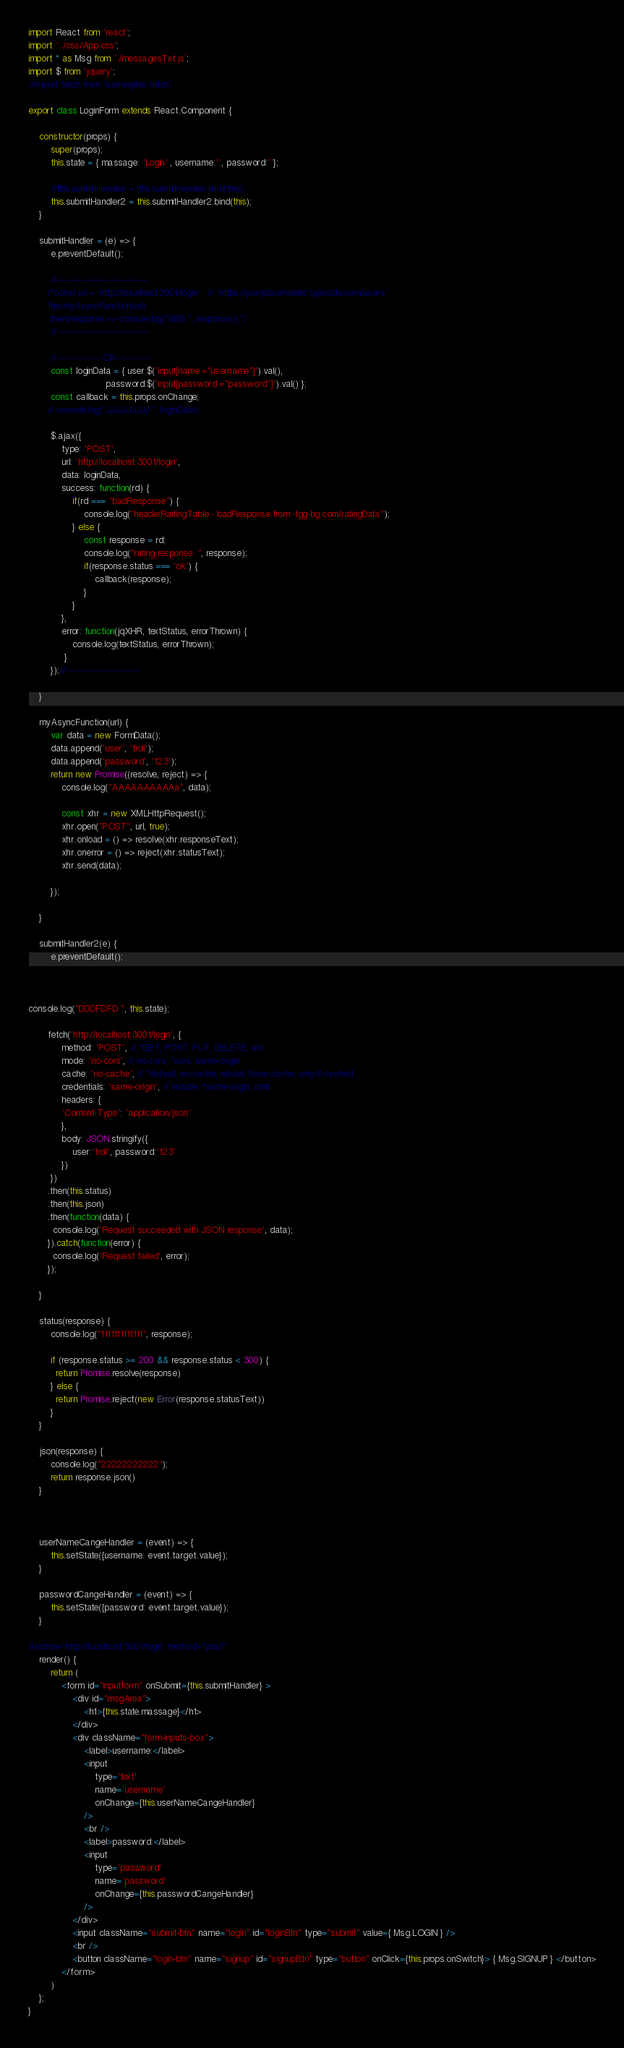<code> <loc_0><loc_0><loc_500><loc_500><_JavaScript_>import React from 'react';
import '../css/App.css';
import * as Msg from './messagesTxt.js';
import $ from 'jquery';
//import fetch from 'isomorphic-fetch';

export class LoginForm extends React.Component {

    constructor(props) {
        super(props);
        this.state = { massage: 'Login' , username:'', password:''};

        //this.submitHandler = this.submitHandler.bind(this);
        this.submitHandler2 = this.submitHandler2.bind(this);
    }

    submitHandler = (e) => {
        e.preventDefault();

        //---------------------------------
       /*const url = 'http://localhost:3001/login';  // 'https://jsonplaceholder.typicode.com/users'
       this.myAsyncFunction(url)
       .then(response => console.log("BBB ", response));*/
        //----------------------------------

        //-----------------OK-------------
        const loginData = { user:$('input[name ="username"]').val(),
                            password:$('input[password ="password"]').val() };
        const callback = this.props.onChange;
       // console.log("JJJJJJJJJJ ", loginData);

        $.ajax({
            type: 'POST',
            url: 'http://localhost:3001/login',
            data: loginData,
            success: function(rd) {
                if(rd === "badResponse") {
                    console.log("headerRaitingTable - badResponse from -tgg-bg.com/ratingData");
                } else {
                    const response = rd;
                    console.log("rating response: ", response);
                    if(response.status === 'ok') {
                        callback(response);
                    }
                }
            },
            error: function(jqXHR, textStatus, errorThrown) {
                console.log(textStatus, errorThrown);
             }
        });//---------------------------

    }

    myAsyncFunction(url) {
        var data = new FormData();
        data.append('user', 'troll');
        data.append('password', '123');
        return new Promise((resolve, reject) => {
            console.log("AAAAAAAAAAa", data);
            
            const xhr = new XMLHttpRequest();
            xhr.open("POST", url, true);
            xhr.onload = () => resolve(xhr.responseText);
            xhr.onerror = () => reject(xhr.statusText);
            xhr.send(data);
          
        });

    }

    submitHandler2(e) {
        e.preventDefault();

        

console.log("DDDFDFD ", this.state);

       fetch('http://localhost:3001/login', {
            method: 'POST', // *GET, POST, PUT, DELETE, etc.
            mode: 'no-cors', // no-cors, *cors, same-origin
            cache: 'no-cache', // *default, no-cache, reload, force-cache, only-if-cached
            credentials: 'same-origin', // include, *same-origin, omit
            headers: {
            'Content-Type': 'application/json'
            },
            body: JSON.stringify({
                user:'troll', password:'123'
            })
        })
       .then(this.status)
       .then(this.json)
       .then(function(data) {
         console.log('Request succeeded with JSON response', data);
       }).catch(function(error) {
         console.log('Request failed', error);
       });
        
    }

    status(response) {
        console.log("1111111111111", response);
        
        if (response.status >= 200 && response.status < 300) {
          return Promise.resolve(response)
        } else {
          return Promise.reject(new Error(response.statusText))
        }
    }
      
    json(response) {
        console.log("22222222222");
        return response.json()
    }
      
      

    userNameCangeHandler = (event) => {
        this.setState({username: event.target.value});
    }

    passwordCangeHandler = (event) => {
        this.setState({password: event.target.value});
    }
    
//action='http://localhost:3001/login' method="post"
    render() {
        return (
            <form id="inputform" onSubmit={this.submitHandler} >
                <div id="msgArea">
                    <h1>{this.state.massage}</h1>
                </div>
                <div className="form-inputs-box">
                    <label>username:</label>
                    <input
                        type='text'
                        name='username'
                        onChange={this.userNameCangeHandler}
                    />
                    <br />
                    <label>password:</label>
                    <input
                        type='password'
                        name='password'
                        onChange={this.passwordCangeHandler}
                    />
                </div>
                <input className="submit-btn" name="login" id="loginBtn" type="submit" value={ Msg.LOGIN } />
                <br />
                <button className="login-btn" name="signup" id="signupBtn" type="button" onClick={this.props.onSwitch}> { Msg.SIGNUP } </button>
            </form>
        )
    };
}</code> 